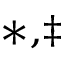<formula> <loc_0><loc_0><loc_500><loc_500>^ { \ast , \ddagger }</formula> 